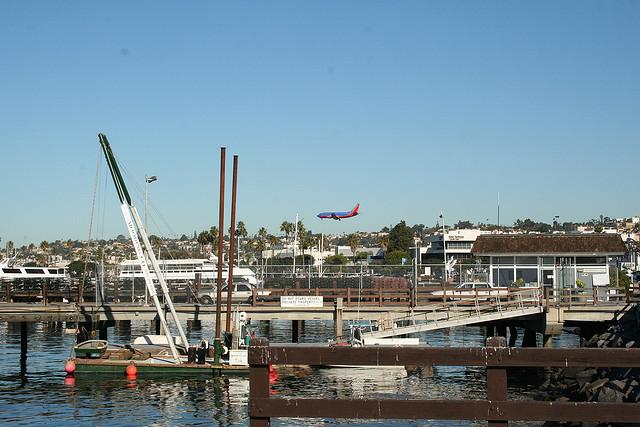What is soaring through the air?

Choices:
A) bat
B) kite
C) zeppelin
D) airplane airplane 